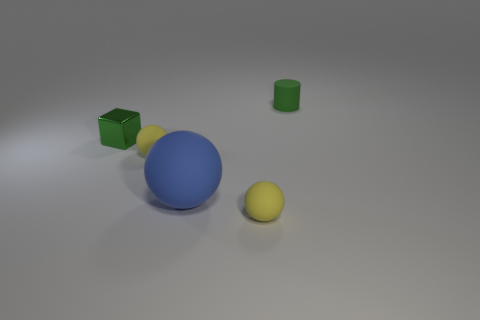What number of small rubber things are behind the big blue thing?
Your response must be concise. 2. Is there a tiny yellow cylinder?
Make the answer very short. No. There is a matte object on the right side of the tiny sphere that is to the right of the small sphere to the left of the large thing; what color is it?
Ensure brevity in your answer.  Green. Are there any green metal blocks right of the yellow thing that is on the left side of the big thing?
Keep it short and to the point. No. Is the color of the matte thing behind the green shiny block the same as the tiny matte object that is in front of the big rubber thing?
Keep it short and to the point. No. What number of matte things are the same size as the green rubber cylinder?
Keep it short and to the point. 2. There is a green object behind the green shiny block; does it have the same size as the big sphere?
Give a very brief answer. No. What shape is the green rubber object?
Offer a very short reply. Cylinder. There is a shiny cube that is the same color as the matte cylinder; what size is it?
Provide a succinct answer. Small. Are the tiny green thing that is behind the shiny object and the large object made of the same material?
Make the answer very short. Yes. 